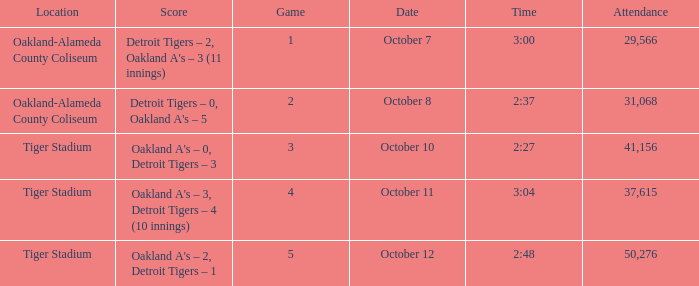What is the number of people in attendance at Oakland-Alameda County Coliseum, and game is 2? 31068.0. 